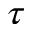<formula> <loc_0><loc_0><loc_500><loc_500>\tau</formula> 